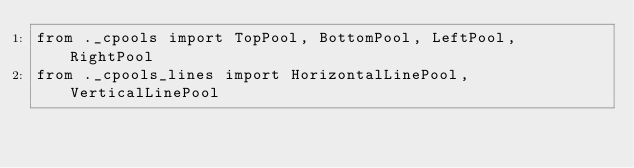Convert code to text. <code><loc_0><loc_0><loc_500><loc_500><_Python_>from ._cpools import TopPool, BottomPool, LeftPool, RightPool
from ._cpools_lines import HorizontalLinePool, VerticalLinePool
</code> 